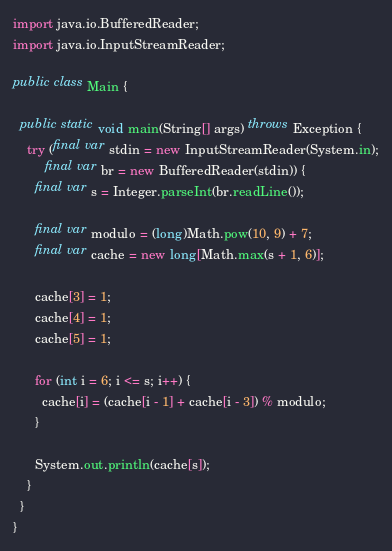<code> <loc_0><loc_0><loc_500><loc_500><_Java_>import java.io.BufferedReader;
import java.io.InputStreamReader;

public class Main {

  public static void main(String[] args) throws Exception {
    try (final var stdin = new InputStreamReader(System.in);
         final var br = new BufferedReader(stdin)) {
      final var s = Integer.parseInt(br.readLine());

      final var modulo = (long)Math.pow(10, 9) + 7;
      final var cache = new long[Math.max(s + 1, 6)];

      cache[3] = 1;
      cache[4] = 1;
      cache[5] = 1;

      for (int i = 6; i <= s; i++) {
        cache[i] = (cache[i - 1] + cache[i - 3]) % modulo;
      }

      System.out.println(cache[s]);
    }
  }
}
</code> 